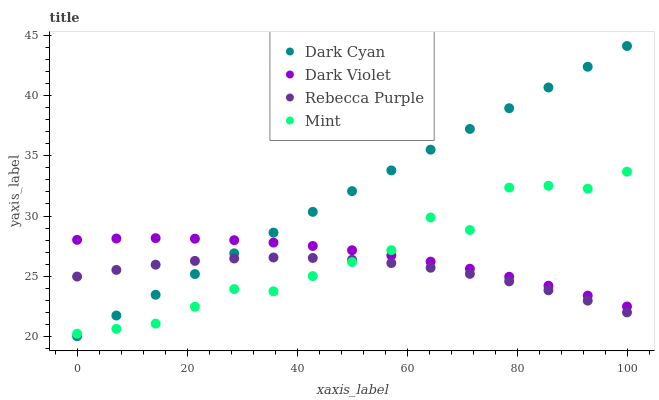Does Rebecca Purple have the minimum area under the curve?
Answer yes or no. Yes. Does Dark Cyan have the maximum area under the curve?
Answer yes or no. Yes. Does Mint have the minimum area under the curve?
Answer yes or no. No. Does Mint have the maximum area under the curve?
Answer yes or no. No. Is Dark Cyan the smoothest?
Answer yes or no. Yes. Is Mint the roughest?
Answer yes or no. Yes. Is Rebecca Purple the smoothest?
Answer yes or no. No. Is Rebecca Purple the roughest?
Answer yes or no. No. Does Dark Cyan have the lowest value?
Answer yes or no. Yes. Does Mint have the lowest value?
Answer yes or no. No. Does Dark Cyan have the highest value?
Answer yes or no. Yes. Does Mint have the highest value?
Answer yes or no. No. Is Rebecca Purple less than Dark Violet?
Answer yes or no. Yes. Is Dark Violet greater than Rebecca Purple?
Answer yes or no. Yes. Does Mint intersect Dark Cyan?
Answer yes or no. Yes. Is Mint less than Dark Cyan?
Answer yes or no. No. Is Mint greater than Dark Cyan?
Answer yes or no. No. Does Rebecca Purple intersect Dark Violet?
Answer yes or no. No. 